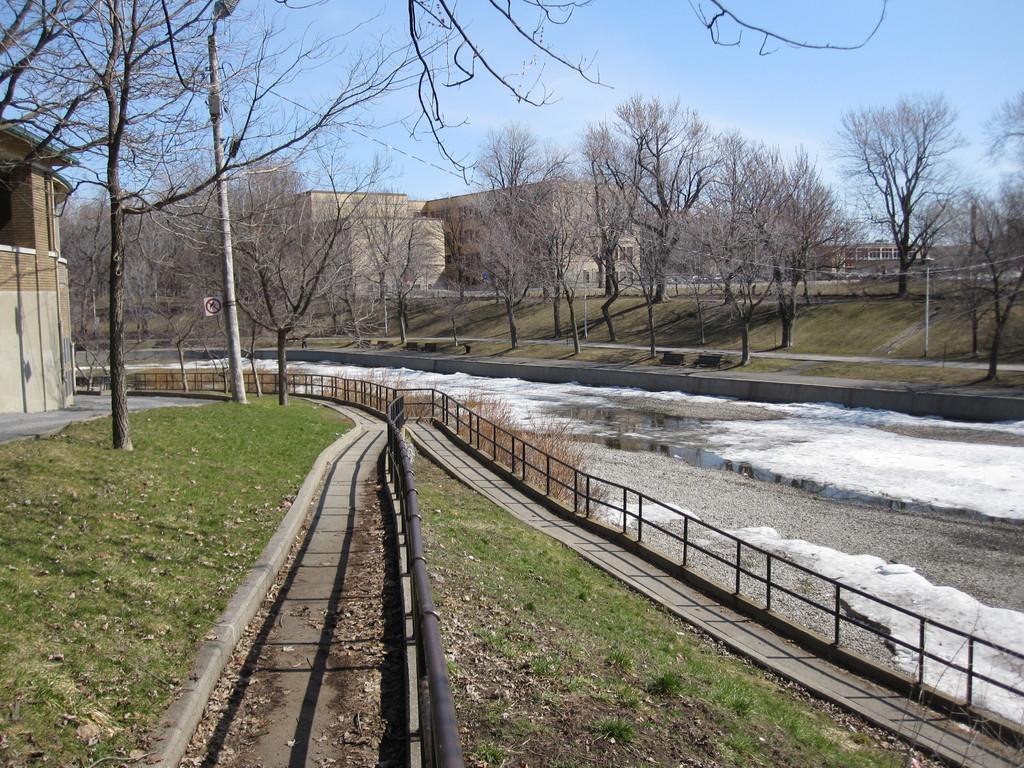Describe this image in one or two sentences. On the left side, there are trees, a pole, building and grass on the ground. On the right side, there is a fencing and water of a lake. In the middle, there is a fencing. Beside this, there is a path. In the background, there are trees, buildings and grass on the ground and there are clouds in the blue sky. 